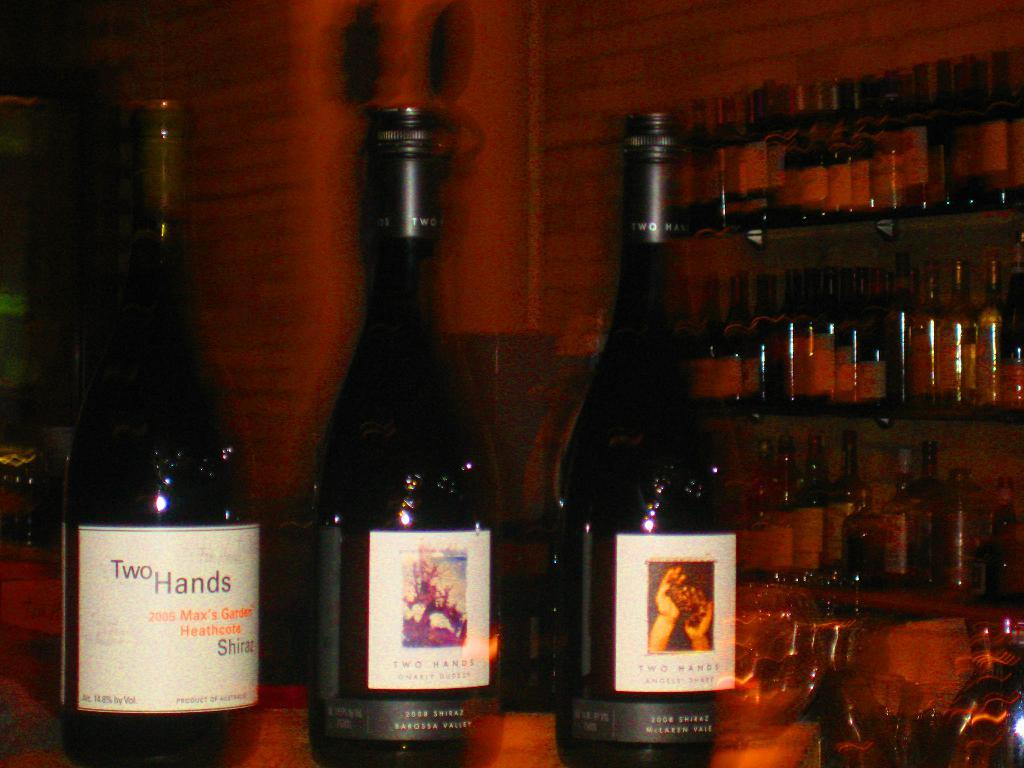<image>
Relay a brief, clear account of the picture shown. Various bottles of Two Hands brand wine with white labels and black foil capping. 